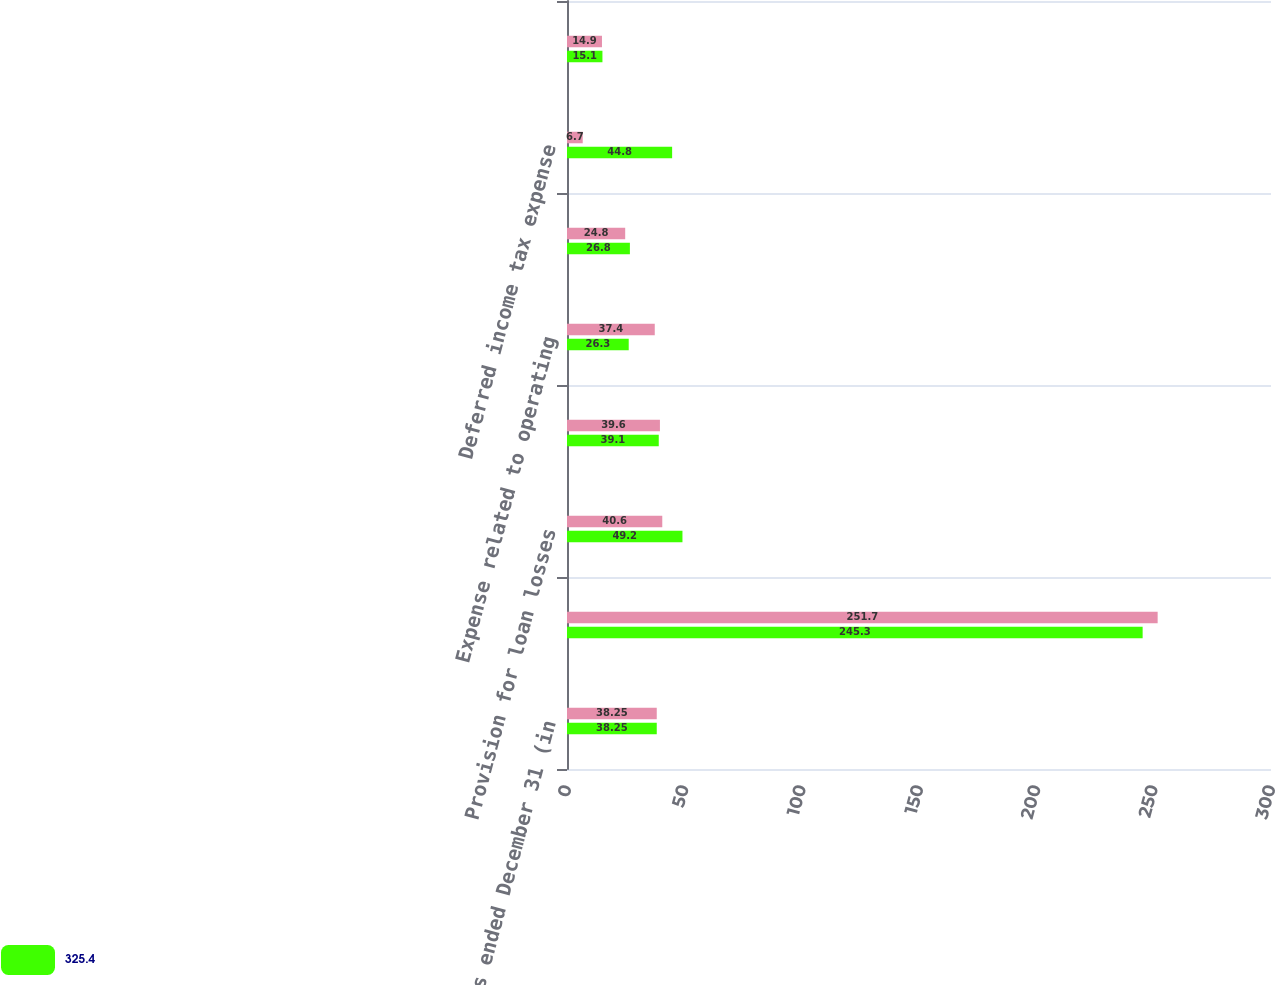<chart> <loc_0><loc_0><loc_500><loc_500><stacked_bar_chart><ecel><fcel>Years ended December 31 (in<fcel>Net income<fcel>Provision for loan losses<fcel>Depreciation and amortization<fcel>Expense related to operating<fcel>Amortization of other<fcel>Deferred income tax expense<fcel>Expense related to share-based<nl><fcel>nan<fcel>38.25<fcel>251.7<fcel>40.6<fcel>39.6<fcel>37.4<fcel>24.8<fcel>6.7<fcel>14.9<nl><fcel>325.4<fcel>38.25<fcel>245.3<fcel>49.2<fcel>39.1<fcel>26.3<fcel>26.8<fcel>44.8<fcel>15.1<nl></chart> 